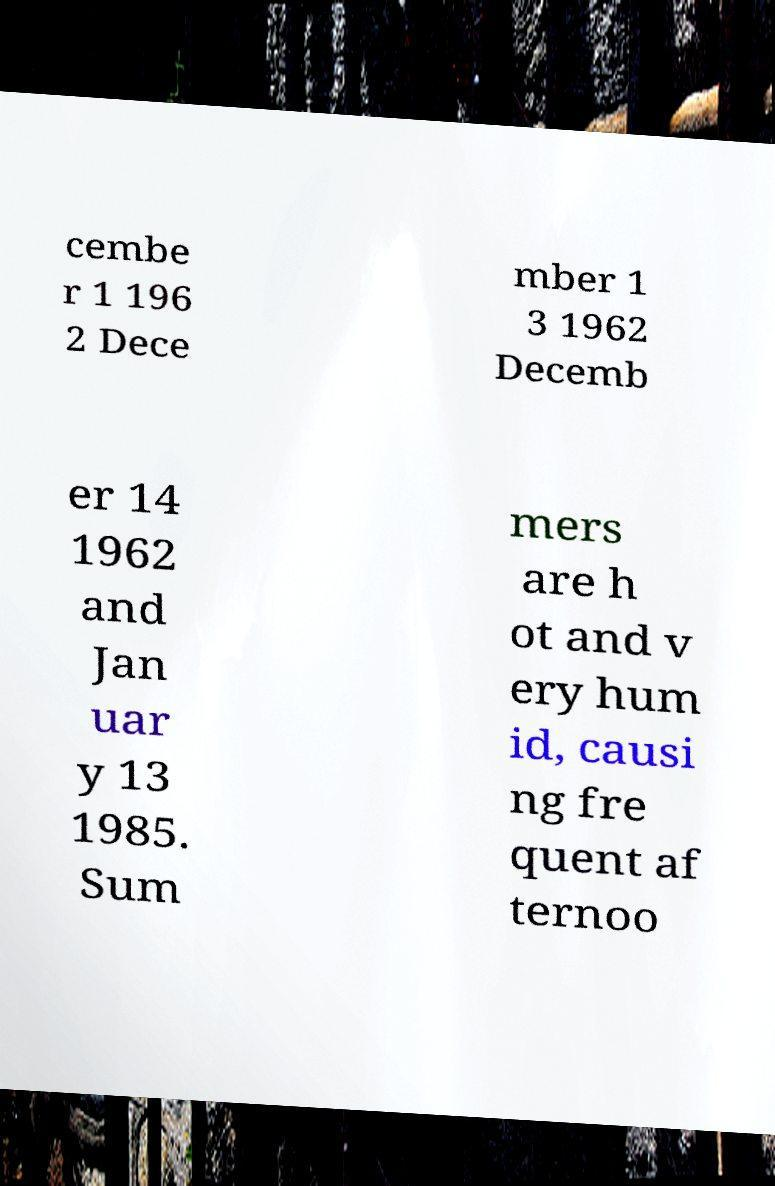For documentation purposes, I need the text within this image transcribed. Could you provide that? cembe r 1 196 2 Dece mber 1 3 1962 Decemb er 14 1962 and Jan uar y 13 1985. Sum mers are h ot and v ery hum id, causi ng fre quent af ternoo 